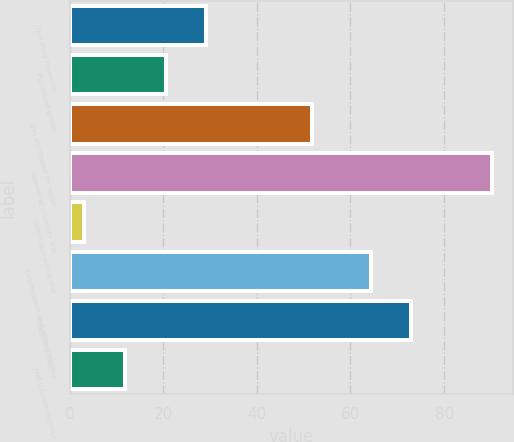<chart> <loc_0><loc_0><loc_500><loc_500><bar_chart><fcel>Operating revenues<fcel>Purchased power<fcel>Gas purchased for resale<fcel>Operating revenues less<fcel>Other operations and<fcel>Depreciation and amortization<fcel>Operating income<fcel>Net interest expense<nl><fcel>29.23<fcel>20.52<fcel>51.7<fcel>90.2<fcel>3.1<fcel>64.3<fcel>73.01<fcel>11.81<nl></chart> 